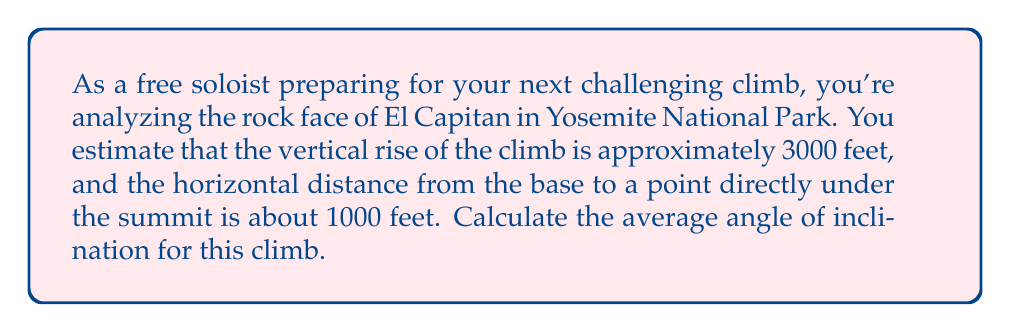Can you solve this math problem? To solve this problem, we need to use trigonometry. The angle of inclination is the angle formed between the horizontal plane and the slope of the rock face. We can calculate this using the arctangent function.

Let's break it down step-by-step:

1. Identify the known values:
   - Vertical rise (height) = 3000 feet
   - Horizontal distance = 1000 feet

2. Visualize the problem as a right triangle:
   [asy]
   import geometry;
   
   size(200);
   
   pair A = (0,0), B = (10,0), C = (10,30);
   draw(A--B--C--A);
   
   label("1000 ft", (A+B)/2, S);
   label("3000 ft", (B+C)/2, E);
   label("θ", A, SW);
   
   draw(rightanglemark(A,B,C,2));
   [/asy]

3. Use the arctangent function to calculate the angle:
   $$ \theta = \arctan(\frac{\text{opposite}}{\text{adjacent}}) = \arctan(\frac{\text{vertical rise}}{\text{horizontal distance}}) $$

4. Plug in the values:
   $$ \theta = \arctan(\frac{3000}{1000}) = \arctan(3) $$

5. Calculate the result:
   $$ \theta \approx 71.57° $$

The arctangent function typically returns the result in radians, so we need to convert it to degrees for a more intuitive understanding in this context.
Answer: The average angle of inclination for the climb is approximately $71.57°$. 